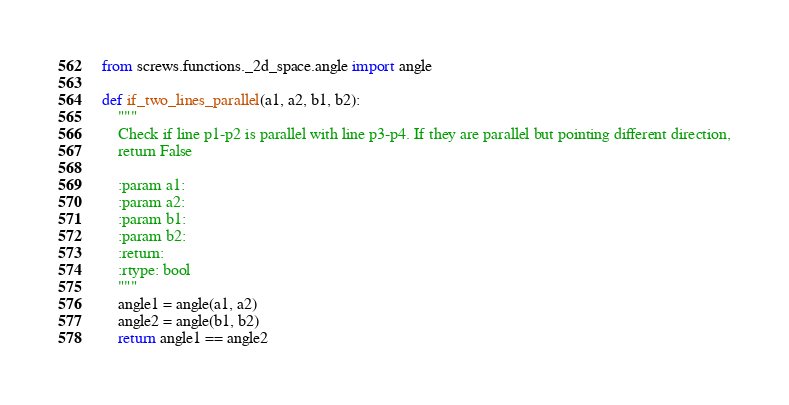<code> <loc_0><loc_0><loc_500><loc_500><_Python_>
from screws.functions._2d_space.angle import angle

def if_two_lines_parallel(a1, a2, b1, b2):
    """
    Check if line p1-p2 is parallel with line p3-p4. If they are parallel but pointing different direction,
    return False

    :param a1:
    :param a2:
    :param b1:
    :param b2:
    :return:
    :rtype: bool
    """
    angle1 = angle(a1, a2)
    angle2 = angle(b1, b2)
    return angle1 == angle2
</code> 